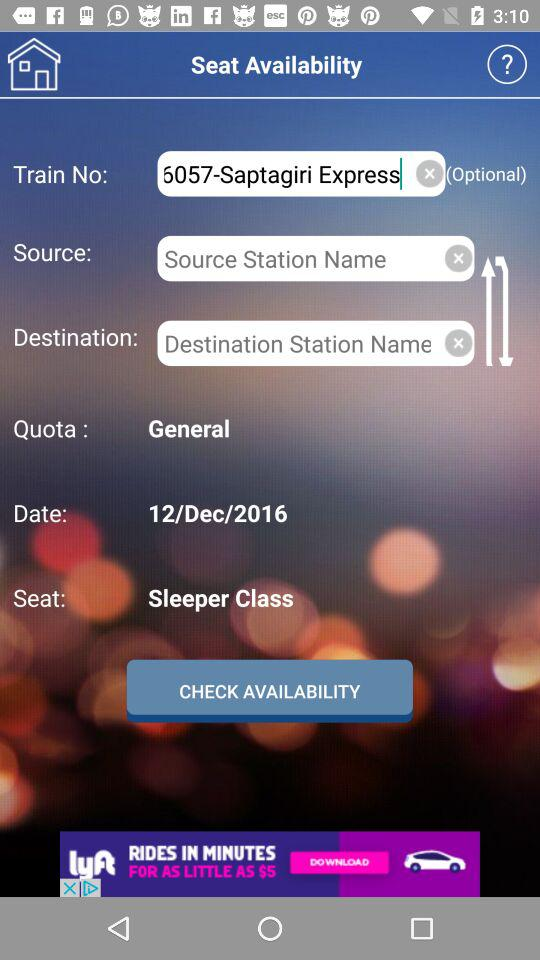What is the date of the journey? The date of the journey is December 12, 2016. 